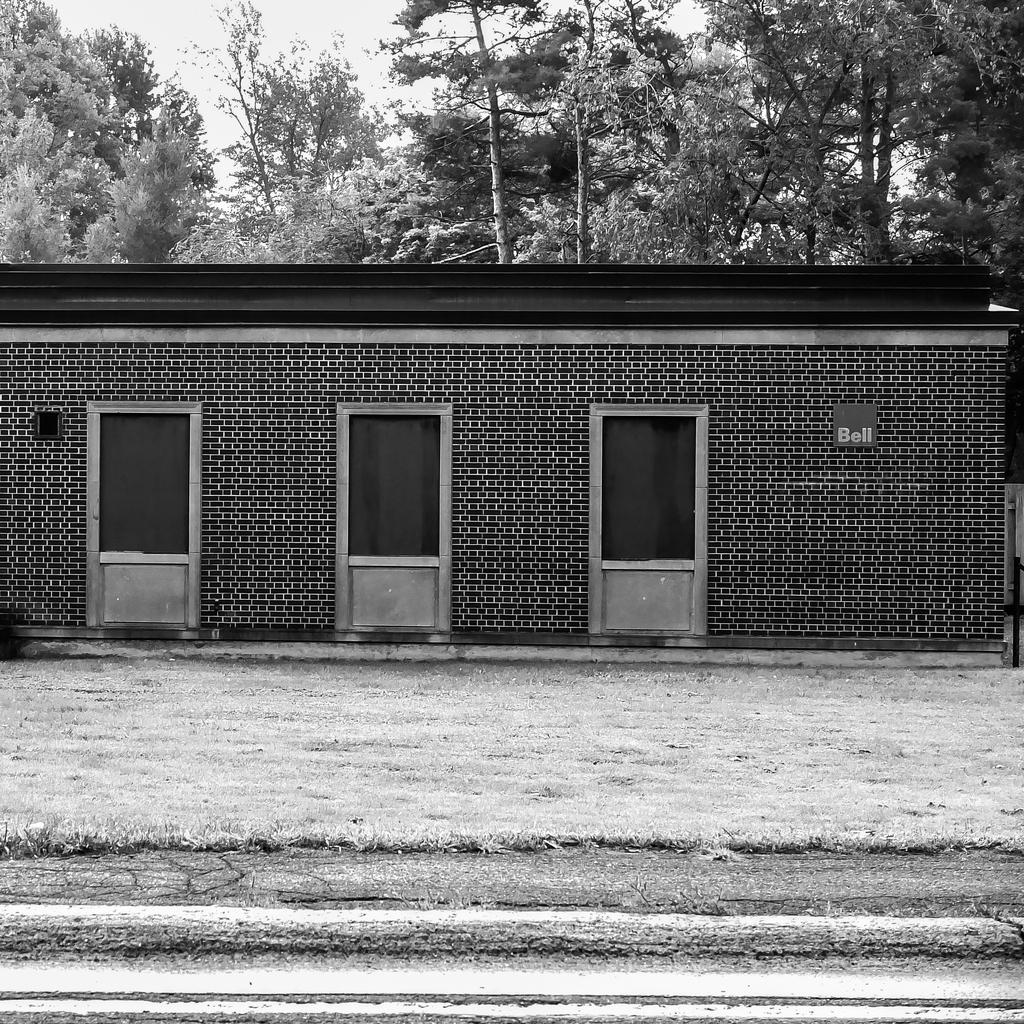How many doors can be seen in the image? There are three doors in the image. What is the relationship between the doors and the building? The doors are attached to a building. What can be seen in the background of the image? There is a tree and the sky visible in the background of the image. What is the color scheme of the image? The image is in black and white. What type of animals can be seen in the zoo in the image? There is no zoo present in the image; it features three doors attached to a building. Can you tell me which card is being held by the person in the image? There is no person or card present in the image. 